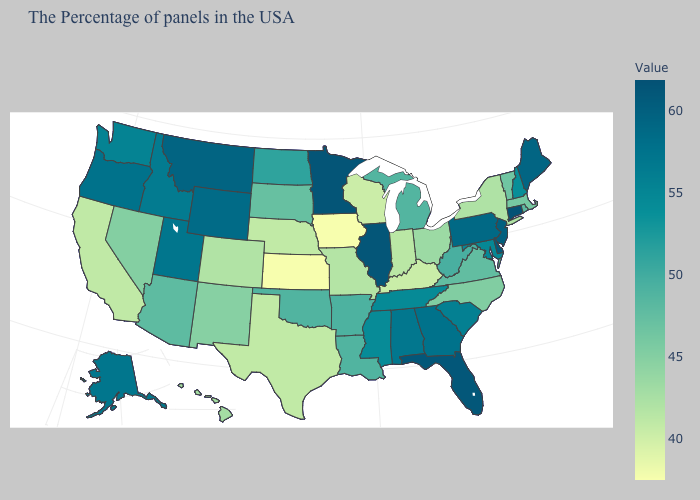Among the states that border Utah , does Wyoming have the highest value?
Be succinct. Yes. Does the map have missing data?
Concise answer only. No. Does Texas have the lowest value in the South?
Answer briefly. No. Does South Dakota have the lowest value in the MidWest?
Keep it brief. No. Does Connecticut have the highest value in the Northeast?
Concise answer only. Yes. 